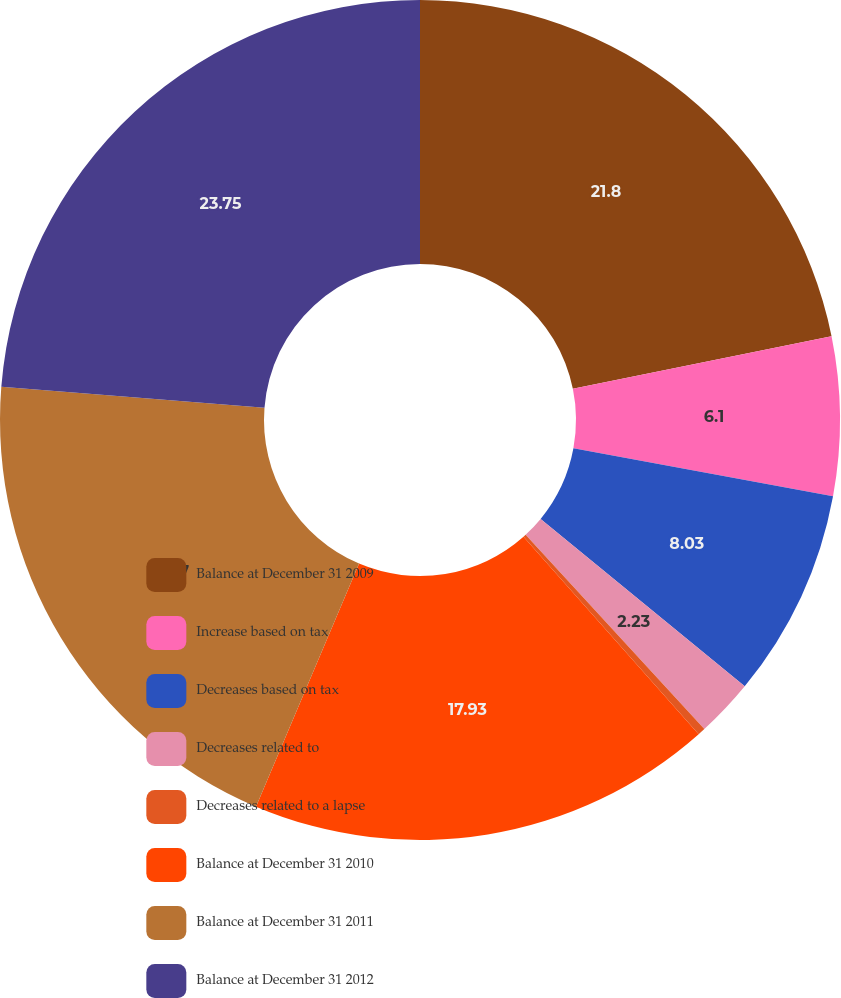Convert chart. <chart><loc_0><loc_0><loc_500><loc_500><pie_chart><fcel>Balance at December 31 2009<fcel>Increase based on tax<fcel>Decreases based on tax<fcel>Decreases related to<fcel>Decreases related to a lapse<fcel>Balance at December 31 2010<fcel>Balance at December 31 2011<fcel>Balance at December 31 2012<nl><fcel>21.8%<fcel>6.1%<fcel>8.03%<fcel>2.23%<fcel>0.29%<fcel>17.93%<fcel>19.87%<fcel>23.74%<nl></chart> 